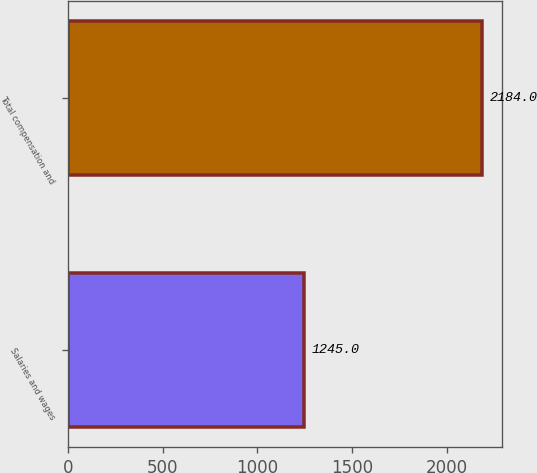Convert chart. <chart><loc_0><loc_0><loc_500><loc_500><bar_chart><fcel>Salaries and wages<fcel>Total compensation and<nl><fcel>1245<fcel>2184<nl></chart> 